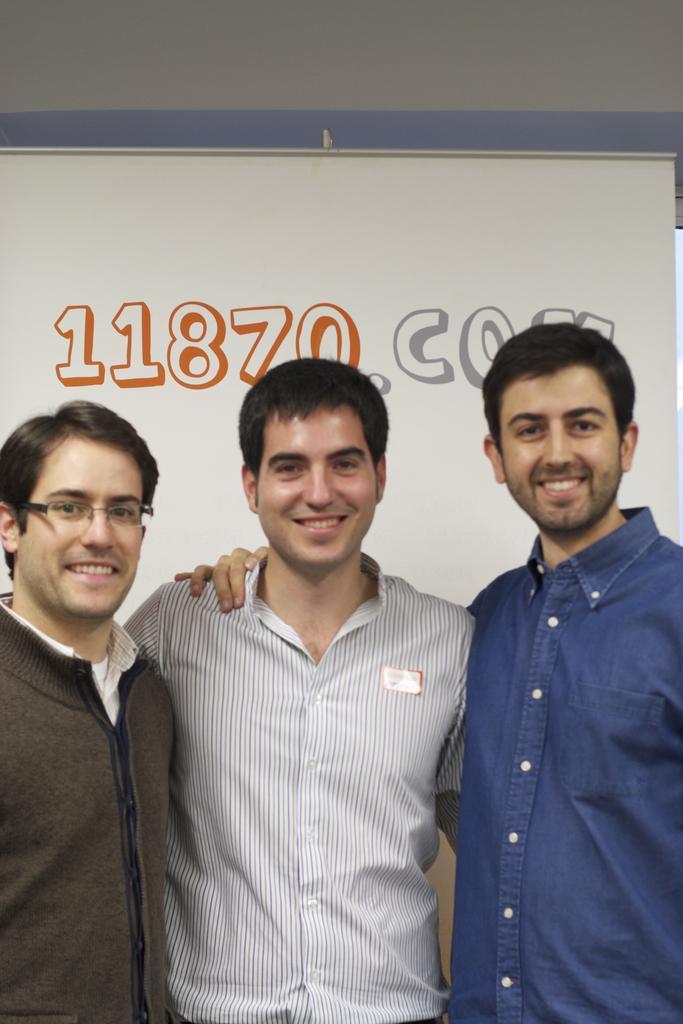Could you give a brief overview of what you see in this image? In this picture there are three persons standing and smiling. At the back there is a text and there is a number on the board. At the top there is a wall. 